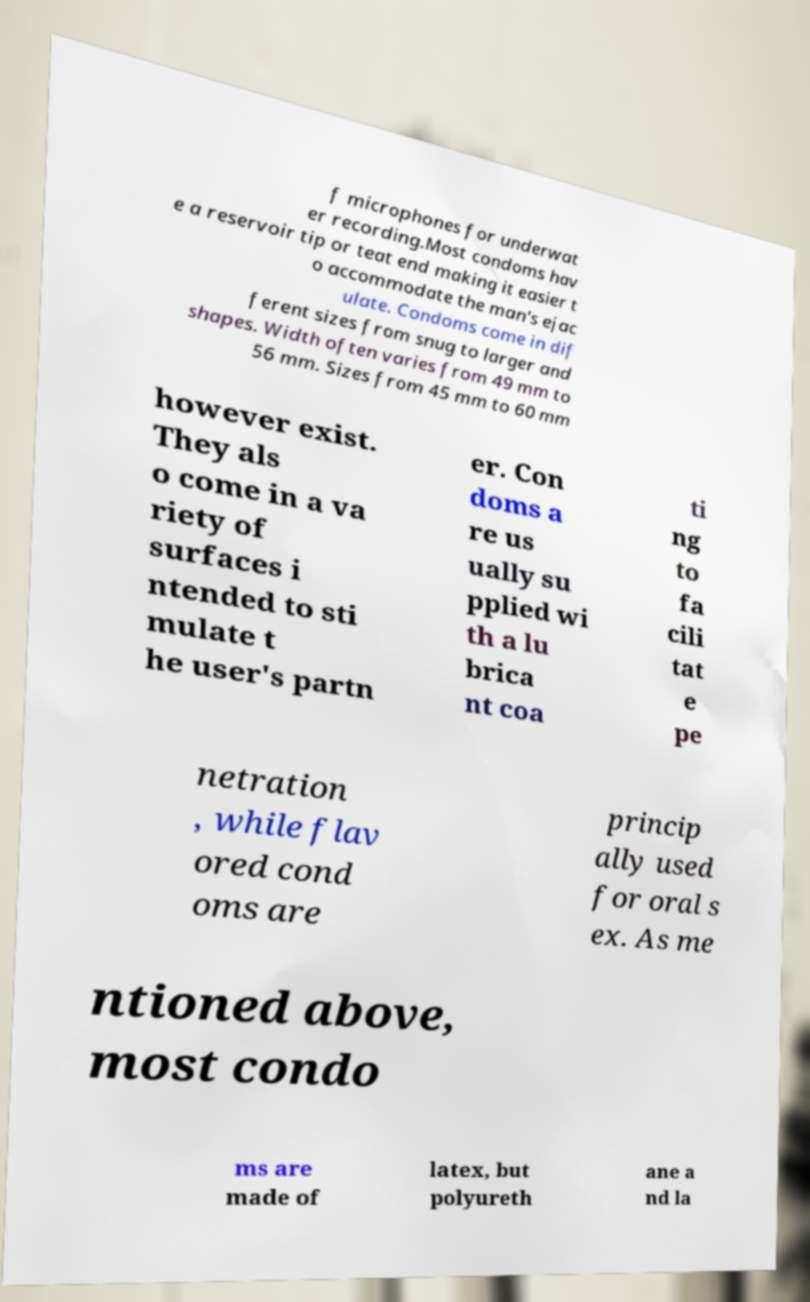For documentation purposes, I need the text within this image transcribed. Could you provide that? f microphones for underwat er recording.Most condoms hav e a reservoir tip or teat end making it easier t o accommodate the man's ejac ulate. Condoms come in dif ferent sizes from snug to larger and shapes. Width often varies from 49 mm to 56 mm. Sizes from 45 mm to 60 mm however exist. They als o come in a va riety of surfaces i ntended to sti mulate t he user's partn er. Con doms a re us ually su pplied wi th a lu brica nt coa ti ng to fa cili tat e pe netration , while flav ored cond oms are princip ally used for oral s ex. As me ntioned above, most condo ms are made of latex, but polyureth ane a nd la 